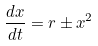Convert formula to latex. <formula><loc_0><loc_0><loc_500><loc_500>\frac { d x } { d t } = r \pm x ^ { 2 }</formula> 